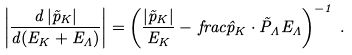Convert formula to latex. <formula><loc_0><loc_0><loc_500><loc_500>\left | \frac { d \, | \vec { p } _ { K } | } { d ( E _ { K } + E _ { \Lambda } ) } \right | = \left ( \frac { | \vec { p } _ { K } | } { E _ { K } } - \, f r a c { \hat { p } _ { K } \cdot \vec { P } _ { \Lambda } } { E _ { \Lambda } } \right ) ^ { - 1 } \, .</formula> 